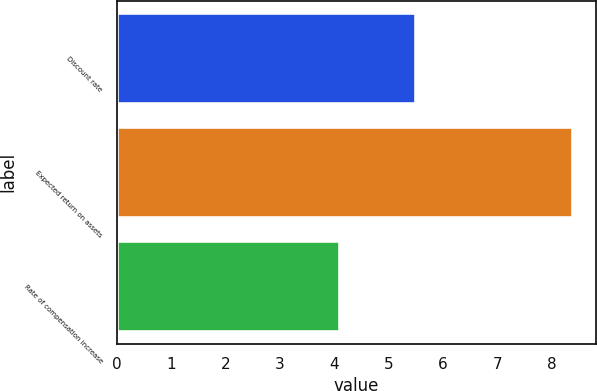Convert chart to OTSL. <chart><loc_0><loc_0><loc_500><loc_500><bar_chart><fcel>Discount rate<fcel>Expected return on assets<fcel>Rate of compensation increase<nl><fcel>5.5<fcel>8.4<fcel>4.1<nl></chart> 